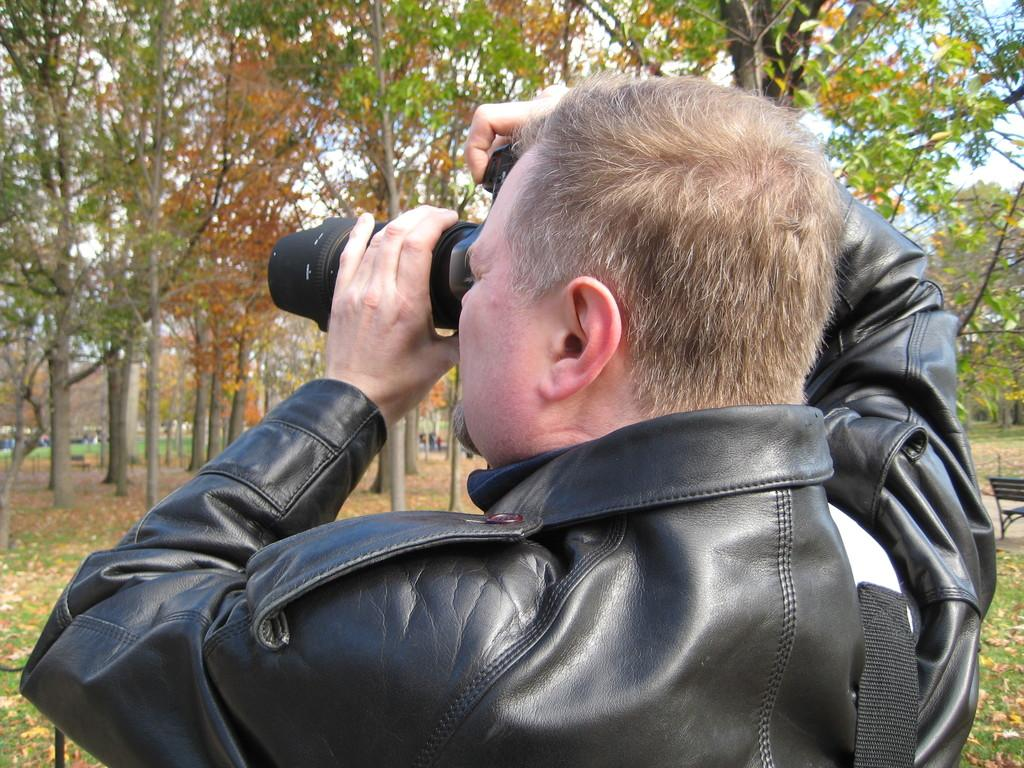What is the main subject of the image? The main subject of the image is a man. What is the man wearing? The man is wearing a jacket. What is the man holding in the image? The man is holding a camera. What is the man doing with the camera? The man is taking pictures. What can be seen in the background of the image? There is a tree, grass, some persons, and a bench in the background of the image. How deep is the snow in the image? There is no snow present in the image. What type of knot is the man using to secure the camera to the tree? The man is not using a knot to secure the camera to the tree; he is simply holding it. 